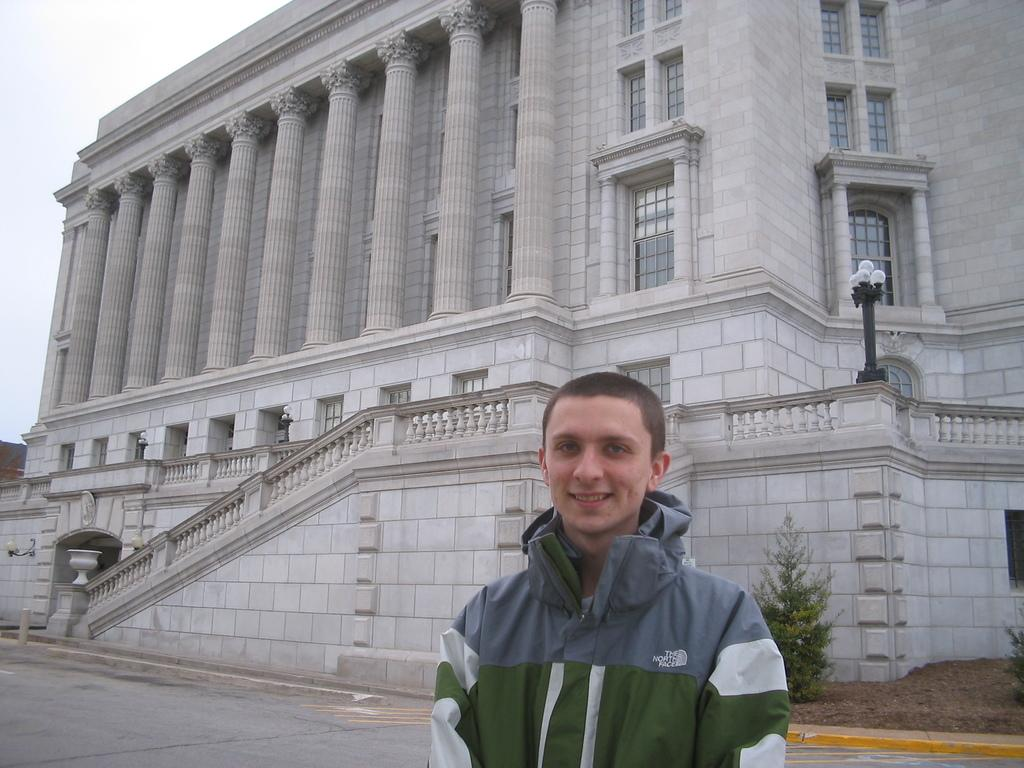<image>
Create a compact narrative representing the image presented. A teenage boy wearing a The North Face coat is standing outside of a large gray brick building. 